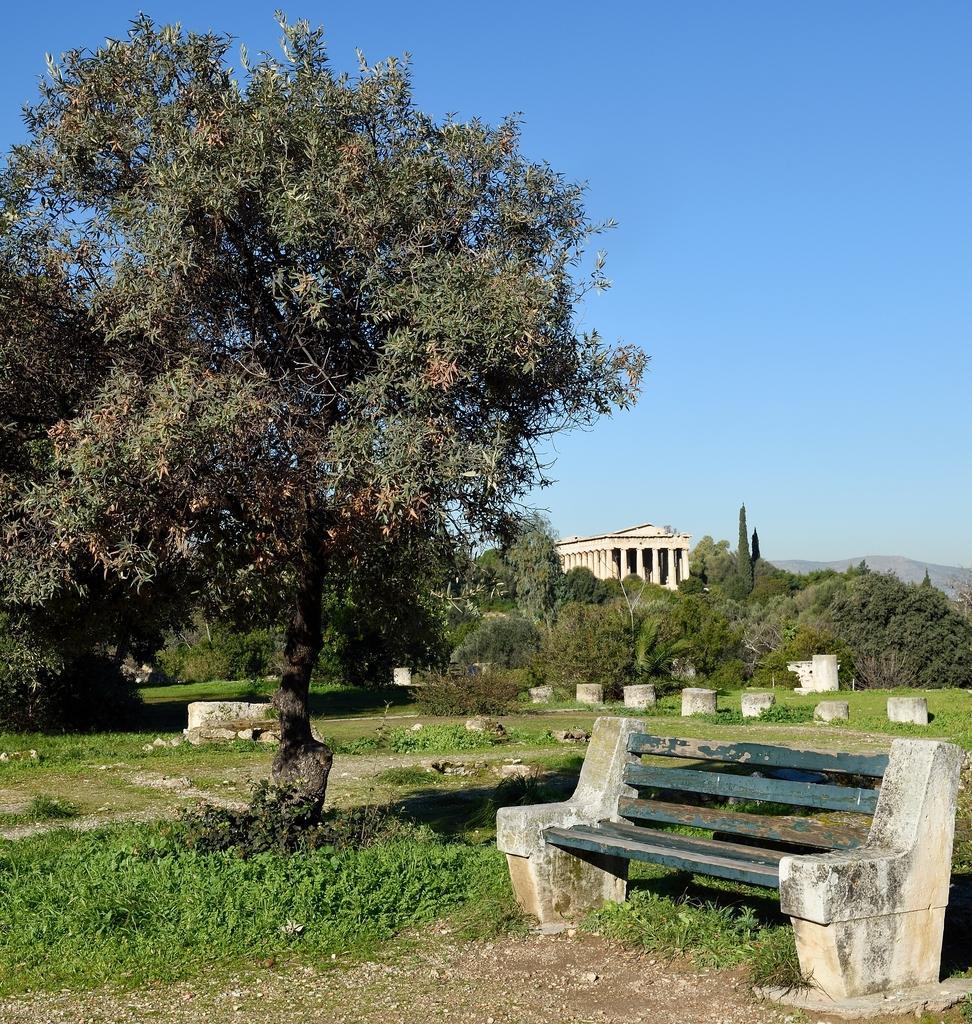Could you give a brief overview of what you see in this image? In this picture we can see a bench on the left side. We can see some plants and few stones on the path. There are few trees and a building in the background. 